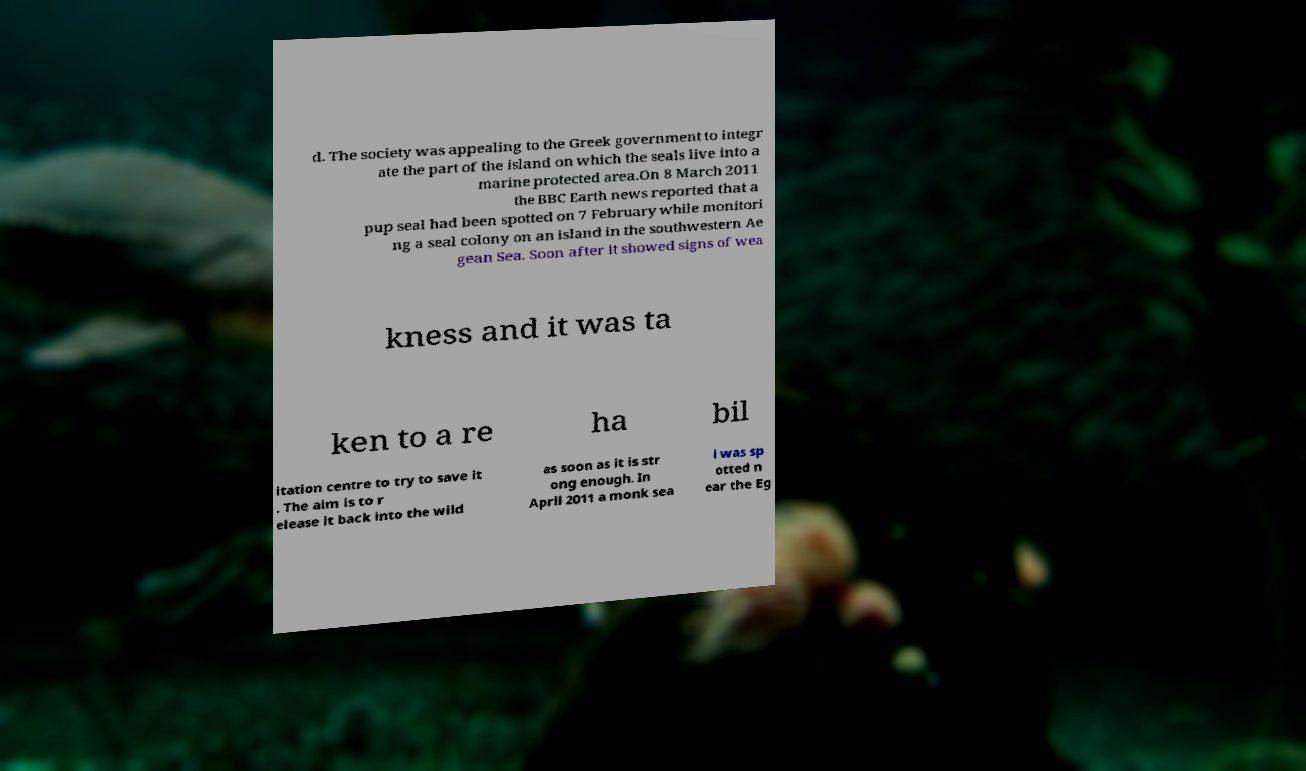Could you assist in decoding the text presented in this image and type it out clearly? d. The society was appealing to the Greek government to integr ate the part of the island on which the seals live into a marine protected area.On 8 March 2011 the BBC Earth news reported that a pup seal had been spotted on 7 February while monitori ng a seal colony on an island in the southwestern Ae gean Sea. Soon after it showed signs of wea kness and it was ta ken to a re ha bil itation centre to try to save it . The aim is to r elease it back into the wild as soon as it is str ong enough. In April 2011 a monk sea l was sp otted n ear the Eg 